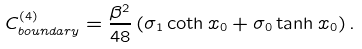<formula> <loc_0><loc_0><loc_500><loc_500>C _ { b o u n d a r y } ^ { ( 4 ) } = \frac { \beta ^ { 2 } } { 4 8 } \left ( \sigma _ { 1 } \coth x _ { 0 } + \sigma _ { 0 } \tanh x _ { 0 } \right ) .</formula> 